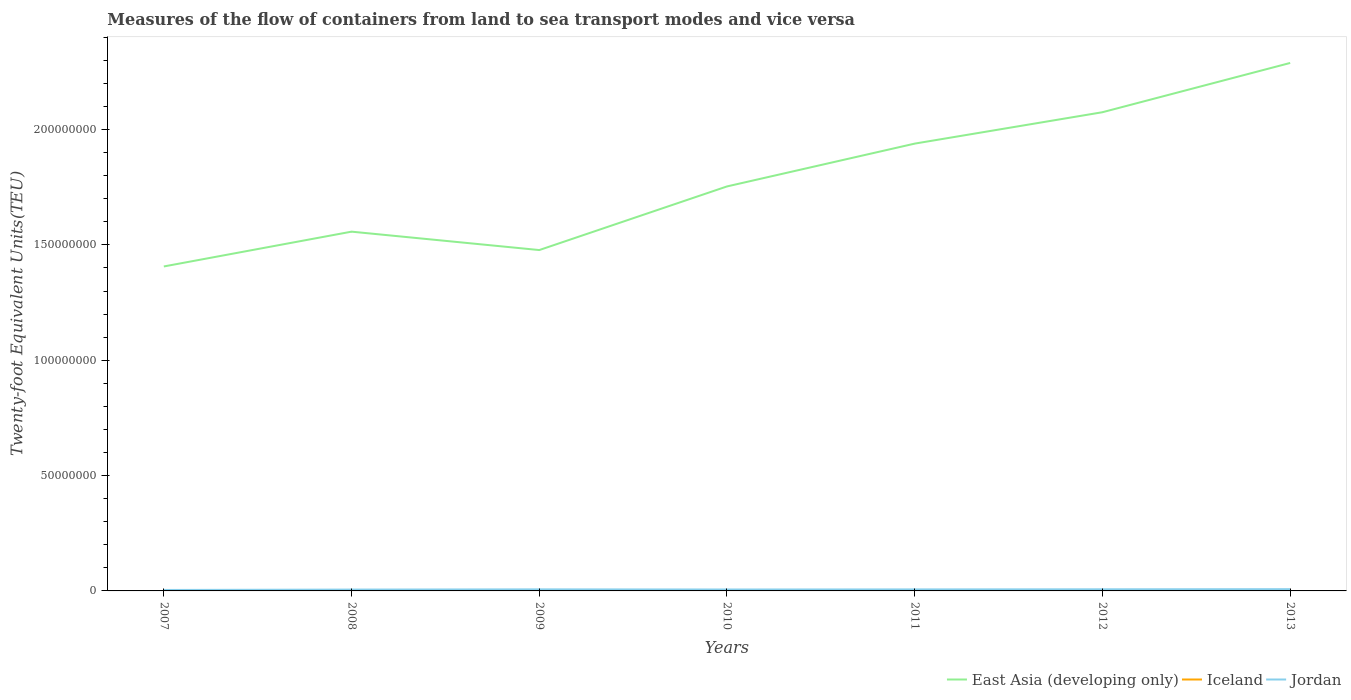Does the line corresponding to Jordan intersect with the line corresponding to East Asia (developing only)?
Offer a terse response. No. Is the number of lines equal to the number of legend labels?
Make the answer very short. Yes. Across all years, what is the maximum container port traffic in Iceland?
Keep it short and to the point. 1.93e+05. In which year was the container port traffic in East Asia (developing only) maximum?
Your answer should be very brief. 2007. What is the total container port traffic in East Asia (developing only) in the graph?
Keep it short and to the point. -6.69e+07. What is the difference between the highest and the second highest container port traffic in Jordan?
Make the answer very short. 3.45e+05. What is the difference between the highest and the lowest container port traffic in Iceland?
Keep it short and to the point. 2. Is the container port traffic in East Asia (developing only) strictly greater than the container port traffic in Iceland over the years?
Give a very brief answer. No. How many lines are there?
Your answer should be compact. 3. How many years are there in the graph?
Provide a short and direct response. 7. Are the values on the major ticks of Y-axis written in scientific E-notation?
Provide a short and direct response. No. Does the graph contain any zero values?
Ensure brevity in your answer.  No. Does the graph contain grids?
Your answer should be very brief. No. Where does the legend appear in the graph?
Provide a succinct answer. Bottom right. How many legend labels are there?
Your answer should be very brief. 3. What is the title of the graph?
Offer a very short reply. Measures of the flow of containers from land to sea transport modes and vice versa. Does "Luxembourg" appear as one of the legend labels in the graph?
Your response must be concise. No. What is the label or title of the Y-axis?
Provide a succinct answer. Twenty-foot Equivalent Units(TEU). What is the Twenty-foot Equivalent Units(TEU) in East Asia (developing only) in 2007?
Your response must be concise. 1.41e+08. What is the Twenty-foot Equivalent Units(TEU) of Iceland in 2007?
Offer a terse response. 2.92e+05. What is the Twenty-foot Equivalent Units(TEU) in Jordan in 2007?
Your answer should be very brief. 4.14e+05. What is the Twenty-foot Equivalent Units(TEU) in East Asia (developing only) in 2008?
Provide a succinct answer. 1.56e+08. What is the Twenty-foot Equivalent Units(TEU) of Iceland in 2008?
Your answer should be very brief. 2.67e+05. What is the Twenty-foot Equivalent Units(TEU) of Jordan in 2008?
Your answer should be compact. 5.83e+05. What is the Twenty-foot Equivalent Units(TEU) in East Asia (developing only) in 2009?
Your answer should be compact. 1.48e+08. What is the Twenty-foot Equivalent Units(TEU) in Iceland in 2009?
Keep it short and to the point. 1.94e+05. What is the Twenty-foot Equivalent Units(TEU) in Jordan in 2009?
Offer a very short reply. 6.75e+05. What is the Twenty-foot Equivalent Units(TEU) of East Asia (developing only) in 2010?
Your answer should be very brief. 1.75e+08. What is the Twenty-foot Equivalent Units(TEU) of Iceland in 2010?
Ensure brevity in your answer.  1.93e+05. What is the Twenty-foot Equivalent Units(TEU) in Jordan in 2010?
Your answer should be compact. 6.19e+05. What is the Twenty-foot Equivalent Units(TEU) in East Asia (developing only) in 2011?
Make the answer very short. 1.94e+08. What is the Twenty-foot Equivalent Units(TEU) in Iceland in 2011?
Your response must be concise. 1.94e+05. What is the Twenty-foot Equivalent Units(TEU) in Jordan in 2011?
Provide a short and direct response. 6.54e+05. What is the Twenty-foot Equivalent Units(TEU) in East Asia (developing only) in 2012?
Offer a terse response. 2.07e+08. What is the Twenty-foot Equivalent Units(TEU) of Iceland in 2012?
Your response must be concise. 2.08e+05. What is the Twenty-foot Equivalent Units(TEU) of Jordan in 2012?
Keep it short and to the point. 7.03e+05. What is the Twenty-foot Equivalent Units(TEU) of East Asia (developing only) in 2013?
Your answer should be compact. 2.29e+08. What is the Twenty-foot Equivalent Units(TEU) in Iceland in 2013?
Make the answer very short. 2.24e+05. What is the Twenty-foot Equivalent Units(TEU) of Jordan in 2013?
Your answer should be compact. 7.59e+05. Across all years, what is the maximum Twenty-foot Equivalent Units(TEU) of East Asia (developing only)?
Give a very brief answer. 2.29e+08. Across all years, what is the maximum Twenty-foot Equivalent Units(TEU) of Iceland?
Provide a short and direct response. 2.92e+05. Across all years, what is the maximum Twenty-foot Equivalent Units(TEU) in Jordan?
Keep it short and to the point. 7.59e+05. Across all years, what is the minimum Twenty-foot Equivalent Units(TEU) in East Asia (developing only)?
Your response must be concise. 1.41e+08. Across all years, what is the minimum Twenty-foot Equivalent Units(TEU) in Iceland?
Your answer should be compact. 1.93e+05. Across all years, what is the minimum Twenty-foot Equivalent Units(TEU) in Jordan?
Your answer should be very brief. 4.14e+05. What is the total Twenty-foot Equivalent Units(TEU) in East Asia (developing only) in the graph?
Provide a short and direct response. 1.25e+09. What is the total Twenty-foot Equivalent Units(TEU) in Iceland in the graph?
Make the answer very short. 1.57e+06. What is the total Twenty-foot Equivalent Units(TEU) in Jordan in the graph?
Make the answer very short. 4.41e+06. What is the difference between the Twenty-foot Equivalent Units(TEU) in East Asia (developing only) in 2007 and that in 2008?
Your answer should be very brief. -1.51e+07. What is the difference between the Twenty-foot Equivalent Units(TEU) of Iceland in 2007 and that in 2008?
Keep it short and to the point. 2.46e+04. What is the difference between the Twenty-foot Equivalent Units(TEU) of Jordan in 2007 and that in 2008?
Ensure brevity in your answer.  -1.69e+05. What is the difference between the Twenty-foot Equivalent Units(TEU) in East Asia (developing only) in 2007 and that in 2009?
Provide a short and direct response. -7.11e+06. What is the difference between the Twenty-foot Equivalent Units(TEU) in Iceland in 2007 and that in 2009?
Give a very brief answer. 9.79e+04. What is the difference between the Twenty-foot Equivalent Units(TEU) in Jordan in 2007 and that in 2009?
Provide a short and direct response. -2.61e+05. What is the difference between the Twenty-foot Equivalent Units(TEU) of East Asia (developing only) in 2007 and that in 2010?
Provide a short and direct response. -3.47e+07. What is the difference between the Twenty-foot Equivalent Units(TEU) of Iceland in 2007 and that in 2010?
Offer a very short reply. 9.90e+04. What is the difference between the Twenty-foot Equivalent Units(TEU) in Jordan in 2007 and that in 2010?
Give a very brief answer. -2.05e+05. What is the difference between the Twenty-foot Equivalent Units(TEU) of East Asia (developing only) in 2007 and that in 2011?
Keep it short and to the point. -5.32e+07. What is the difference between the Twenty-foot Equivalent Units(TEU) of Iceland in 2007 and that in 2011?
Offer a very short reply. 9.82e+04. What is the difference between the Twenty-foot Equivalent Units(TEU) in Jordan in 2007 and that in 2011?
Make the answer very short. -2.40e+05. What is the difference between the Twenty-foot Equivalent Units(TEU) of East Asia (developing only) in 2007 and that in 2012?
Give a very brief answer. -6.69e+07. What is the difference between the Twenty-foot Equivalent Units(TEU) of Iceland in 2007 and that in 2012?
Give a very brief answer. 8.37e+04. What is the difference between the Twenty-foot Equivalent Units(TEU) of Jordan in 2007 and that in 2012?
Your response must be concise. -2.89e+05. What is the difference between the Twenty-foot Equivalent Units(TEU) in East Asia (developing only) in 2007 and that in 2013?
Offer a very short reply. -8.82e+07. What is the difference between the Twenty-foot Equivalent Units(TEU) in Iceland in 2007 and that in 2013?
Ensure brevity in your answer.  6.73e+04. What is the difference between the Twenty-foot Equivalent Units(TEU) of Jordan in 2007 and that in 2013?
Keep it short and to the point. -3.45e+05. What is the difference between the Twenty-foot Equivalent Units(TEU) in East Asia (developing only) in 2008 and that in 2009?
Offer a terse response. 7.97e+06. What is the difference between the Twenty-foot Equivalent Units(TEU) of Iceland in 2008 and that in 2009?
Your answer should be compact. 7.33e+04. What is the difference between the Twenty-foot Equivalent Units(TEU) in Jordan in 2008 and that in 2009?
Offer a terse response. -9.20e+04. What is the difference between the Twenty-foot Equivalent Units(TEU) in East Asia (developing only) in 2008 and that in 2010?
Offer a very short reply. -1.96e+07. What is the difference between the Twenty-foot Equivalent Units(TEU) of Iceland in 2008 and that in 2010?
Offer a terse response. 7.44e+04. What is the difference between the Twenty-foot Equivalent Units(TEU) in Jordan in 2008 and that in 2010?
Offer a terse response. -3.65e+04. What is the difference between the Twenty-foot Equivalent Units(TEU) of East Asia (developing only) in 2008 and that in 2011?
Your answer should be very brief. -3.82e+07. What is the difference between the Twenty-foot Equivalent Units(TEU) of Iceland in 2008 and that in 2011?
Keep it short and to the point. 7.37e+04. What is the difference between the Twenty-foot Equivalent Units(TEU) of Jordan in 2008 and that in 2011?
Offer a terse response. -7.18e+04. What is the difference between the Twenty-foot Equivalent Units(TEU) of East Asia (developing only) in 2008 and that in 2012?
Ensure brevity in your answer.  -5.18e+07. What is the difference between the Twenty-foot Equivalent Units(TEU) of Iceland in 2008 and that in 2012?
Your response must be concise. 5.91e+04. What is the difference between the Twenty-foot Equivalent Units(TEU) in Jordan in 2008 and that in 2012?
Offer a terse response. -1.21e+05. What is the difference between the Twenty-foot Equivalent Units(TEU) in East Asia (developing only) in 2008 and that in 2013?
Provide a short and direct response. -7.31e+07. What is the difference between the Twenty-foot Equivalent Units(TEU) of Iceland in 2008 and that in 2013?
Offer a terse response. 4.27e+04. What is the difference between the Twenty-foot Equivalent Units(TEU) in Jordan in 2008 and that in 2013?
Your answer should be compact. -1.76e+05. What is the difference between the Twenty-foot Equivalent Units(TEU) in East Asia (developing only) in 2009 and that in 2010?
Ensure brevity in your answer.  -2.76e+07. What is the difference between the Twenty-foot Equivalent Units(TEU) in Iceland in 2009 and that in 2010?
Give a very brief answer. 1038. What is the difference between the Twenty-foot Equivalent Units(TEU) in Jordan in 2009 and that in 2010?
Offer a very short reply. 5.55e+04. What is the difference between the Twenty-foot Equivalent Units(TEU) in East Asia (developing only) in 2009 and that in 2011?
Your answer should be very brief. -4.61e+07. What is the difference between the Twenty-foot Equivalent Units(TEU) in Iceland in 2009 and that in 2011?
Ensure brevity in your answer.  316. What is the difference between the Twenty-foot Equivalent Units(TEU) in Jordan in 2009 and that in 2011?
Ensure brevity in your answer.  2.02e+04. What is the difference between the Twenty-foot Equivalent Units(TEU) of East Asia (developing only) in 2009 and that in 2012?
Make the answer very short. -5.97e+07. What is the difference between the Twenty-foot Equivalent Units(TEU) of Iceland in 2009 and that in 2012?
Ensure brevity in your answer.  -1.42e+04. What is the difference between the Twenty-foot Equivalent Units(TEU) in Jordan in 2009 and that in 2012?
Your answer should be compact. -2.88e+04. What is the difference between the Twenty-foot Equivalent Units(TEU) of East Asia (developing only) in 2009 and that in 2013?
Ensure brevity in your answer.  -8.11e+07. What is the difference between the Twenty-foot Equivalent Units(TEU) in Iceland in 2009 and that in 2013?
Keep it short and to the point. -3.06e+04. What is the difference between the Twenty-foot Equivalent Units(TEU) in Jordan in 2009 and that in 2013?
Give a very brief answer. -8.44e+04. What is the difference between the Twenty-foot Equivalent Units(TEU) in East Asia (developing only) in 2010 and that in 2011?
Provide a succinct answer. -1.86e+07. What is the difference between the Twenty-foot Equivalent Units(TEU) in Iceland in 2010 and that in 2011?
Make the answer very short. -722. What is the difference between the Twenty-foot Equivalent Units(TEU) in Jordan in 2010 and that in 2011?
Offer a terse response. -3.53e+04. What is the difference between the Twenty-foot Equivalent Units(TEU) of East Asia (developing only) in 2010 and that in 2012?
Offer a very short reply. -3.22e+07. What is the difference between the Twenty-foot Equivalent Units(TEU) in Iceland in 2010 and that in 2012?
Offer a very short reply. -1.52e+04. What is the difference between the Twenty-foot Equivalent Units(TEU) in Jordan in 2010 and that in 2012?
Your answer should be very brief. -8.44e+04. What is the difference between the Twenty-foot Equivalent Units(TEU) of East Asia (developing only) in 2010 and that in 2013?
Ensure brevity in your answer.  -5.35e+07. What is the difference between the Twenty-foot Equivalent Units(TEU) of Iceland in 2010 and that in 2013?
Offer a very short reply. -3.17e+04. What is the difference between the Twenty-foot Equivalent Units(TEU) of Jordan in 2010 and that in 2013?
Your answer should be very brief. -1.40e+05. What is the difference between the Twenty-foot Equivalent Units(TEU) of East Asia (developing only) in 2011 and that in 2012?
Make the answer very short. -1.36e+07. What is the difference between the Twenty-foot Equivalent Units(TEU) of Iceland in 2011 and that in 2012?
Provide a succinct answer. -1.45e+04. What is the difference between the Twenty-foot Equivalent Units(TEU) of Jordan in 2011 and that in 2012?
Offer a very short reply. -4.91e+04. What is the difference between the Twenty-foot Equivalent Units(TEU) in East Asia (developing only) in 2011 and that in 2013?
Your response must be concise. -3.50e+07. What is the difference between the Twenty-foot Equivalent Units(TEU) of Iceland in 2011 and that in 2013?
Your answer should be very brief. -3.09e+04. What is the difference between the Twenty-foot Equivalent Units(TEU) in Jordan in 2011 and that in 2013?
Provide a short and direct response. -1.05e+05. What is the difference between the Twenty-foot Equivalent Units(TEU) of East Asia (developing only) in 2012 and that in 2013?
Your answer should be compact. -2.14e+07. What is the difference between the Twenty-foot Equivalent Units(TEU) of Iceland in 2012 and that in 2013?
Offer a terse response. -1.64e+04. What is the difference between the Twenty-foot Equivalent Units(TEU) of Jordan in 2012 and that in 2013?
Provide a succinct answer. -5.56e+04. What is the difference between the Twenty-foot Equivalent Units(TEU) in East Asia (developing only) in 2007 and the Twenty-foot Equivalent Units(TEU) in Iceland in 2008?
Give a very brief answer. 1.40e+08. What is the difference between the Twenty-foot Equivalent Units(TEU) of East Asia (developing only) in 2007 and the Twenty-foot Equivalent Units(TEU) of Jordan in 2008?
Provide a succinct answer. 1.40e+08. What is the difference between the Twenty-foot Equivalent Units(TEU) of Iceland in 2007 and the Twenty-foot Equivalent Units(TEU) of Jordan in 2008?
Offer a very short reply. -2.91e+05. What is the difference between the Twenty-foot Equivalent Units(TEU) of East Asia (developing only) in 2007 and the Twenty-foot Equivalent Units(TEU) of Iceland in 2009?
Your answer should be very brief. 1.40e+08. What is the difference between the Twenty-foot Equivalent Units(TEU) of East Asia (developing only) in 2007 and the Twenty-foot Equivalent Units(TEU) of Jordan in 2009?
Your response must be concise. 1.40e+08. What is the difference between the Twenty-foot Equivalent Units(TEU) in Iceland in 2007 and the Twenty-foot Equivalent Units(TEU) in Jordan in 2009?
Offer a terse response. -3.83e+05. What is the difference between the Twenty-foot Equivalent Units(TEU) in East Asia (developing only) in 2007 and the Twenty-foot Equivalent Units(TEU) in Iceland in 2010?
Provide a short and direct response. 1.40e+08. What is the difference between the Twenty-foot Equivalent Units(TEU) in East Asia (developing only) in 2007 and the Twenty-foot Equivalent Units(TEU) in Jordan in 2010?
Keep it short and to the point. 1.40e+08. What is the difference between the Twenty-foot Equivalent Units(TEU) of Iceland in 2007 and the Twenty-foot Equivalent Units(TEU) of Jordan in 2010?
Your answer should be very brief. -3.27e+05. What is the difference between the Twenty-foot Equivalent Units(TEU) in East Asia (developing only) in 2007 and the Twenty-foot Equivalent Units(TEU) in Iceland in 2011?
Offer a very short reply. 1.40e+08. What is the difference between the Twenty-foot Equivalent Units(TEU) of East Asia (developing only) in 2007 and the Twenty-foot Equivalent Units(TEU) of Jordan in 2011?
Your answer should be compact. 1.40e+08. What is the difference between the Twenty-foot Equivalent Units(TEU) of Iceland in 2007 and the Twenty-foot Equivalent Units(TEU) of Jordan in 2011?
Your answer should be very brief. -3.63e+05. What is the difference between the Twenty-foot Equivalent Units(TEU) in East Asia (developing only) in 2007 and the Twenty-foot Equivalent Units(TEU) in Iceland in 2012?
Your response must be concise. 1.40e+08. What is the difference between the Twenty-foot Equivalent Units(TEU) in East Asia (developing only) in 2007 and the Twenty-foot Equivalent Units(TEU) in Jordan in 2012?
Offer a terse response. 1.40e+08. What is the difference between the Twenty-foot Equivalent Units(TEU) in Iceland in 2007 and the Twenty-foot Equivalent Units(TEU) in Jordan in 2012?
Offer a very short reply. -4.12e+05. What is the difference between the Twenty-foot Equivalent Units(TEU) in East Asia (developing only) in 2007 and the Twenty-foot Equivalent Units(TEU) in Iceland in 2013?
Give a very brief answer. 1.40e+08. What is the difference between the Twenty-foot Equivalent Units(TEU) of East Asia (developing only) in 2007 and the Twenty-foot Equivalent Units(TEU) of Jordan in 2013?
Provide a short and direct response. 1.40e+08. What is the difference between the Twenty-foot Equivalent Units(TEU) of Iceland in 2007 and the Twenty-foot Equivalent Units(TEU) of Jordan in 2013?
Keep it short and to the point. -4.67e+05. What is the difference between the Twenty-foot Equivalent Units(TEU) in East Asia (developing only) in 2008 and the Twenty-foot Equivalent Units(TEU) in Iceland in 2009?
Your answer should be compact. 1.56e+08. What is the difference between the Twenty-foot Equivalent Units(TEU) of East Asia (developing only) in 2008 and the Twenty-foot Equivalent Units(TEU) of Jordan in 2009?
Provide a succinct answer. 1.55e+08. What is the difference between the Twenty-foot Equivalent Units(TEU) in Iceland in 2008 and the Twenty-foot Equivalent Units(TEU) in Jordan in 2009?
Provide a short and direct response. -4.07e+05. What is the difference between the Twenty-foot Equivalent Units(TEU) in East Asia (developing only) in 2008 and the Twenty-foot Equivalent Units(TEU) in Iceland in 2010?
Provide a succinct answer. 1.56e+08. What is the difference between the Twenty-foot Equivalent Units(TEU) of East Asia (developing only) in 2008 and the Twenty-foot Equivalent Units(TEU) of Jordan in 2010?
Your answer should be very brief. 1.55e+08. What is the difference between the Twenty-foot Equivalent Units(TEU) of Iceland in 2008 and the Twenty-foot Equivalent Units(TEU) of Jordan in 2010?
Offer a terse response. -3.52e+05. What is the difference between the Twenty-foot Equivalent Units(TEU) in East Asia (developing only) in 2008 and the Twenty-foot Equivalent Units(TEU) in Iceland in 2011?
Provide a succinct answer. 1.56e+08. What is the difference between the Twenty-foot Equivalent Units(TEU) of East Asia (developing only) in 2008 and the Twenty-foot Equivalent Units(TEU) of Jordan in 2011?
Keep it short and to the point. 1.55e+08. What is the difference between the Twenty-foot Equivalent Units(TEU) of Iceland in 2008 and the Twenty-foot Equivalent Units(TEU) of Jordan in 2011?
Ensure brevity in your answer.  -3.87e+05. What is the difference between the Twenty-foot Equivalent Units(TEU) of East Asia (developing only) in 2008 and the Twenty-foot Equivalent Units(TEU) of Iceland in 2012?
Ensure brevity in your answer.  1.56e+08. What is the difference between the Twenty-foot Equivalent Units(TEU) in East Asia (developing only) in 2008 and the Twenty-foot Equivalent Units(TEU) in Jordan in 2012?
Keep it short and to the point. 1.55e+08. What is the difference between the Twenty-foot Equivalent Units(TEU) of Iceland in 2008 and the Twenty-foot Equivalent Units(TEU) of Jordan in 2012?
Your response must be concise. -4.36e+05. What is the difference between the Twenty-foot Equivalent Units(TEU) in East Asia (developing only) in 2008 and the Twenty-foot Equivalent Units(TEU) in Iceland in 2013?
Provide a succinct answer. 1.56e+08. What is the difference between the Twenty-foot Equivalent Units(TEU) in East Asia (developing only) in 2008 and the Twenty-foot Equivalent Units(TEU) in Jordan in 2013?
Your answer should be compact. 1.55e+08. What is the difference between the Twenty-foot Equivalent Units(TEU) of Iceland in 2008 and the Twenty-foot Equivalent Units(TEU) of Jordan in 2013?
Keep it short and to the point. -4.92e+05. What is the difference between the Twenty-foot Equivalent Units(TEU) in East Asia (developing only) in 2009 and the Twenty-foot Equivalent Units(TEU) in Iceland in 2010?
Ensure brevity in your answer.  1.48e+08. What is the difference between the Twenty-foot Equivalent Units(TEU) of East Asia (developing only) in 2009 and the Twenty-foot Equivalent Units(TEU) of Jordan in 2010?
Give a very brief answer. 1.47e+08. What is the difference between the Twenty-foot Equivalent Units(TEU) in Iceland in 2009 and the Twenty-foot Equivalent Units(TEU) in Jordan in 2010?
Make the answer very short. -4.25e+05. What is the difference between the Twenty-foot Equivalent Units(TEU) in East Asia (developing only) in 2009 and the Twenty-foot Equivalent Units(TEU) in Iceland in 2011?
Offer a terse response. 1.48e+08. What is the difference between the Twenty-foot Equivalent Units(TEU) in East Asia (developing only) in 2009 and the Twenty-foot Equivalent Units(TEU) in Jordan in 2011?
Your answer should be very brief. 1.47e+08. What is the difference between the Twenty-foot Equivalent Units(TEU) in Iceland in 2009 and the Twenty-foot Equivalent Units(TEU) in Jordan in 2011?
Ensure brevity in your answer.  -4.60e+05. What is the difference between the Twenty-foot Equivalent Units(TEU) in East Asia (developing only) in 2009 and the Twenty-foot Equivalent Units(TEU) in Iceland in 2012?
Provide a succinct answer. 1.48e+08. What is the difference between the Twenty-foot Equivalent Units(TEU) of East Asia (developing only) in 2009 and the Twenty-foot Equivalent Units(TEU) of Jordan in 2012?
Make the answer very short. 1.47e+08. What is the difference between the Twenty-foot Equivalent Units(TEU) in Iceland in 2009 and the Twenty-foot Equivalent Units(TEU) in Jordan in 2012?
Make the answer very short. -5.10e+05. What is the difference between the Twenty-foot Equivalent Units(TEU) of East Asia (developing only) in 2009 and the Twenty-foot Equivalent Units(TEU) of Iceland in 2013?
Give a very brief answer. 1.48e+08. What is the difference between the Twenty-foot Equivalent Units(TEU) in East Asia (developing only) in 2009 and the Twenty-foot Equivalent Units(TEU) in Jordan in 2013?
Provide a succinct answer. 1.47e+08. What is the difference between the Twenty-foot Equivalent Units(TEU) in Iceland in 2009 and the Twenty-foot Equivalent Units(TEU) in Jordan in 2013?
Make the answer very short. -5.65e+05. What is the difference between the Twenty-foot Equivalent Units(TEU) in East Asia (developing only) in 2010 and the Twenty-foot Equivalent Units(TEU) in Iceland in 2011?
Your answer should be compact. 1.75e+08. What is the difference between the Twenty-foot Equivalent Units(TEU) of East Asia (developing only) in 2010 and the Twenty-foot Equivalent Units(TEU) of Jordan in 2011?
Make the answer very short. 1.75e+08. What is the difference between the Twenty-foot Equivalent Units(TEU) of Iceland in 2010 and the Twenty-foot Equivalent Units(TEU) of Jordan in 2011?
Provide a succinct answer. -4.62e+05. What is the difference between the Twenty-foot Equivalent Units(TEU) of East Asia (developing only) in 2010 and the Twenty-foot Equivalent Units(TEU) of Iceland in 2012?
Make the answer very short. 1.75e+08. What is the difference between the Twenty-foot Equivalent Units(TEU) in East Asia (developing only) in 2010 and the Twenty-foot Equivalent Units(TEU) in Jordan in 2012?
Provide a short and direct response. 1.75e+08. What is the difference between the Twenty-foot Equivalent Units(TEU) of Iceland in 2010 and the Twenty-foot Equivalent Units(TEU) of Jordan in 2012?
Give a very brief answer. -5.11e+05. What is the difference between the Twenty-foot Equivalent Units(TEU) of East Asia (developing only) in 2010 and the Twenty-foot Equivalent Units(TEU) of Iceland in 2013?
Give a very brief answer. 1.75e+08. What is the difference between the Twenty-foot Equivalent Units(TEU) in East Asia (developing only) in 2010 and the Twenty-foot Equivalent Units(TEU) in Jordan in 2013?
Your response must be concise. 1.75e+08. What is the difference between the Twenty-foot Equivalent Units(TEU) of Iceland in 2010 and the Twenty-foot Equivalent Units(TEU) of Jordan in 2013?
Offer a very short reply. -5.66e+05. What is the difference between the Twenty-foot Equivalent Units(TEU) of East Asia (developing only) in 2011 and the Twenty-foot Equivalent Units(TEU) of Iceland in 2012?
Provide a short and direct response. 1.94e+08. What is the difference between the Twenty-foot Equivalent Units(TEU) in East Asia (developing only) in 2011 and the Twenty-foot Equivalent Units(TEU) in Jordan in 2012?
Offer a very short reply. 1.93e+08. What is the difference between the Twenty-foot Equivalent Units(TEU) in Iceland in 2011 and the Twenty-foot Equivalent Units(TEU) in Jordan in 2012?
Your answer should be compact. -5.10e+05. What is the difference between the Twenty-foot Equivalent Units(TEU) of East Asia (developing only) in 2011 and the Twenty-foot Equivalent Units(TEU) of Iceland in 2013?
Offer a terse response. 1.94e+08. What is the difference between the Twenty-foot Equivalent Units(TEU) in East Asia (developing only) in 2011 and the Twenty-foot Equivalent Units(TEU) in Jordan in 2013?
Make the answer very short. 1.93e+08. What is the difference between the Twenty-foot Equivalent Units(TEU) in Iceland in 2011 and the Twenty-foot Equivalent Units(TEU) in Jordan in 2013?
Give a very brief answer. -5.65e+05. What is the difference between the Twenty-foot Equivalent Units(TEU) of East Asia (developing only) in 2012 and the Twenty-foot Equivalent Units(TEU) of Iceland in 2013?
Offer a very short reply. 2.07e+08. What is the difference between the Twenty-foot Equivalent Units(TEU) of East Asia (developing only) in 2012 and the Twenty-foot Equivalent Units(TEU) of Jordan in 2013?
Your answer should be compact. 2.07e+08. What is the difference between the Twenty-foot Equivalent Units(TEU) of Iceland in 2012 and the Twenty-foot Equivalent Units(TEU) of Jordan in 2013?
Keep it short and to the point. -5.51e+05. What is the average Twenty-foot Equivalent Units(TEU) of East Asia (developing only) per year?
Provide a short and direct response. 1.79e+08. What is the average Twenty-foot Equivalent Units(TEU) of Iceland per year?
Your answer should be very brief. 2.24e+05. What is the average Twenty-foot Equivalent Units(TEU) of Jordan per year?
Make the answer very short. 6.30e+05. In the year 2007, what is the difference between the Twenty-foot Equivalent Units(TEU) in East Asia (developing only) and Twenty-foot Equivalent Units(TEU) in Iceland?
Provide a short and direct response. 1.40e+08. In the year 2007, what is the difference between the Twenty-foot Equivalent Units(TEU) of East Asia (developing only) and Twenty-foot Equivalent Units(TEU) of Jordan?
Your answer should be very brief. 1.40e+08. In the year 2007, what is the difference between the Twenty-foot Equivalent Units(TEU) in Iceland and Twenty-foot Equivalent Units(TEU) in Jordan?
Give a very brief answer. -1.22e+05. In the year 2008, what is the difference between the Twenty-foot Equivalent Units(TEU) of East Asia (developing only) and Twenty-foot Equivalent Units(TEU) of Iceland?
Ensure brevity in your answer.  1.55e+08. In the year 2008, what is the difference between the Twenty-foot Equivalent Units(TEU) in East Asia (developing only) and Twenty-foot Equivalent Units(TEU) in Jordan?
Your response must be concise. 1.55e+08. In the year 2008, what is the difference between the Twenty-foot Equivalent Units(TEU) in Iceland and Twenty-foot Equivalent Units(TEU) in Jordan?
Keep it short and to the point. -3.15e+05. In the year 2009, what is the difference between the Twenty-foot Equivalent Units(TEU) in East Asia (developing only) and Twenty-foot Equivalent Units(TEU) in Iceland?
Offer a very short reply. 1.48e+08. In the year 2009, what is the difference between the Twenty-foot Equivalent Units(TEU) in East Asia (developing only) and Twenty-foot Equivalent Units(TEU) in Jordan?
Your answer should be compact. 1.47e+08. In the year 2009, what is the difference between the Twenty-foot Equivalent Units(TEU) of Iceland and Twenty-foot Equivalent Units(TEU) of Jordan?
Offer a very short reply. -4.81e+05. In the year 2010, what is the difference between the Twenty-foot Equivalent Units(TEU) in East Asia (developing only) and Twenty-foot Equivalent Units(TEU) in Iceland?
Ensure brevity in your answer.  1.75e+08. In the year 2010, what is the difference between the Twenty-foot Equivalent Units(TEU) of East Asia (developing only) and Twenty-foot Equivalent Units(TEU) of Jordan?
Your response must be concise. 1.75e+08. In the year 2010, what is the difference between the Twenty-foot Equivalent Units(TEU) in Iceland and Twenty-foot Equivalent Units(TEU) in Jordan?
Make the answer very short. -4.26e+05. In the year 2011, what is the difference between the Twenty-foot Equivalent Units(TEU) in East Asia (developing only) and Twenty-foot Equivalent Units(TEU) in Iceland?
Offer a very short reply. 1.94e+08. In the year 2011, what is the difference between the Twenty-foot Equivalent Units(TEU) in East Asia (developing only) and Twenty-foot Equivalent Units(TEU) in Jordan?
Your answer should be very brief. 1.93e+08. In the year 2011, what is the difference between the Twenty-foot Equivalent Units(TEU) of Iceland and Twenty-foot Equivalent Units(TEU) of Jordan?
Make the answer very short. -4.61e+05. In the year 2012, what is the difference between the Twenty-foot Equivalent Units(TEU) in East Asia (developing only) and Twenty-foot Equivalent Units(TEU) in Iceland?
Your answer should be very brief. 2.07e+08. In the year 2012, what is the difference between the Twenty-foot Equivalent Units(TEU) in East Asia (developing only) and Twenty-foot Equivalent Units(TEU) in Jordan?
Offer a very short reply. 2.07e+08. In the year 2012, what is the difference between the Twenty-foot Equivalent Units(TEU) of Iceland and Twenty-foot Equivalent Units(TEU) of Jordan?
Keep it short and to the point. -4.95e+05. In the year 2013, what is the difference between the Twenty-foot Equivalent Units(TEU) of East Asia (developing only) and Twenty-foot Equivalent Units(TEU) of Iceland?
Ensure brevity in your answer.  2.29e+08. In the year 2013, what is the difference between the Twenty-foot Equivalent Units(TEU) of East Asia (developing only) and Twenty-foot Equivalent Units(TEU) of Jordan?
Your answer should be compact. 2.28e+08. In the year 2013, what is the difference between the Twenty-foot Equivalent Units(TEU) of Iceland and Twenty-foot Equivalent Units(TEU) of Jordan?
Your answer should be very brief. -5.34e+05. What is the ratio of the Twenty-foot Equivalent Units(TEU) of East Asia (developing only) in 2007 to that in 2008?
Provide a short and direct response. 0.9. What is the ratio of the Twenty-foot Equivalent Units(TEU) in Iceland in 2007 to that in 2008?
Your response must be concise. 1.09. What is the ratio of the Twenty-foot Equivalent Units(TEU) of Jordan in 2007 to that in 2008?
Offer a very short reply. 0.71. What is the ratio of the Twenty-foot Equivalent Units(TEU) in East Asia (developing only) in 2007 to that in 2009?
Provide a succinct answer. 0.95. What is the ratio of the Twenty-foot Equivalent Units(TEU) in Iceland in 2007 to that in 2009?
Provide a short and direct response. 1.51. What is the ratio of the Twenty-foot Equivalent Units(TEU) in Jordan in 2007 to that in 2009?
Provide a short and direct response. 0.61. What is the ratio of the Twenty-foot Equivalent Units(TEU) of East Asia (developing only) in 2007 to that in 2010?
Make the answer very short. 0.8. What is the ratio of the Twenty-foot Equivalent Units(TEU) of Iceland in 2007 to that in 2010?
Make the answer very short. 1.51. What is the ratio of the Twenty-foot Equivalent Units(TEU) in Jordan in 2007 to that in 2010?
Give a very brief answer. 0.67. What is the ratio of the Twenty-foot Equivalent Units(TEU) of East Asia (developing only) in 2007 to that in 2011?
Give a very brief answer. 0.73. What is the ratio of the Twenty-foot Equivalent Units(TEU) in Iceland in 2007 to that in 2011?
Ensure brevity in your answer.  1.51. What is the ratio of the Twenty-foot Equivalent Units(TEU) in Jordan in 2007 to that in 2011?
Your answer should be very brief. 0.63. What is the ratio of the Twenty-foot Equivalent Units(TEU) in East Asia (developing only) in 2007 to that in 2012?
Make the answer very short. 0.68. What is the ratio of the Twenty-foot Equivalent Units(TEU) of Iceland in 2007 to that in 2012?
Give a very brief answer. 1.4. What is the ratio of the Twenty-foot Equivalent Units(TEU) of Jordan in 2007 to that in 2012?
Your response must be concise. 0.59. What is the ratio of the Twenty-foot Equivalent Units(TEU) in East Asia (developing only) in 2007 to that in 2013?
Provide a succinct answer. 0.61. What is the ratio of the Twenty-foot Equivalent Units(TEU) in Iceland in 2007 to that in 2013?
Provide a succinct answer. 1.3. What is the ratio of the Twenty-foot Equivalent Units(TEU) in Jordan in 2007 to that in 2013?
Give a very brief answer. 0.55. What is the ratio of the Twenty-foot Equivalent Units(TEU) in East Asia (developing only) in 2008 to that in 2009?
Make the answer very short. 1.05. What is the ratio of the Twenty-foot Equivalent Units(TEU) in Iceland in 2008 to that in 2009?
Offer a terse response. 1.38. What is the ratio of the Twenty-foot Equivalent Units(TEU) of Jordan in 2008 to that in 2009?
Your response must be concise. 0.86. What is the ratio of the Twenty-foot Equivalent Units(TEU) of East Asia (developing only) in 2008 to that in 2010?
Keep it short and to the point. 0.89. What is the ratio of the Twenty-foot Equivalent Units(TEU) in Iceland in 2008 to that in 2010?
Make the answer very short. 1.39. What is the ratio of the Twenty-foot Equivalent Units(TEU) of Jordan in 2008 to that in 2010?
Keep it short and to the point. 0.94. What is the ratio of the Twenty-foot Equivalent Units(TEU) of East Asia (developing only) in 2008 to that in 2011?
Provide a short and direct response. 0.8. What is the ratio of the Twenty-foot Equivalent Units(TEU) of Iceland in 2008 to that in 2011?
Your answer should be very brief. 1.38. What is the ratio of the Twenty-foot Equivalent Units(TEU) in Jordan in 2008 to that in 2011?
Offer a terse response. 0.89. What is the ratio of the Twenty-foot Equivalent Units(TEU) of East Asia (developing only) in 2008 to that in 2012?
Offer a very short reply. 0.75. What is the ratio of the Twenty-foot Equivalent Units(TEU) of Iceland in 2008 to that in 2012?
Ensure brevity in your answer.  1.28. What is the ratio of the Twenty-foot Equivalent Units(TEU) in Jordan in 2008 to that in 2012?
Provide a succinct answer. 0.83. What is the ratio of the Twenty-foot Equivalent Units(TEU) of East Asia (developing only) in 2008 to that in 2013?
Make the answer very short. 0.68. What is the ratio of the Twenty-foot Equivalent Units(TEU) in Iceland in 2008 to that in 2013?
Give a very brief answer. 1.19. What is the ratio of the Twenty-foot Equivalent Units(TEU) in Jordan in 2008 to that in 2013?
Your answer should be compact. 0.77. What is the ratio of the Twenty-foot Equivalent Units(TEU) of East Asia (developing only) in 2009 to that in 2010?
Make the answer very short. 0.84. What is the ratio of the Twenty-foot Equivalent Units(TEU) in Iceland in 2009 to that in 2010?
Make the answer very short. 1.01. What is the ratio of the Twenty-foot Equivalent Units(TEU) of Jordan in 2009 to that in 2010?
Ensure brevity in your answer.  1.09. What is the ratio of the Twenty-foot Equivalent Units(TEU) in East Asia (developing only) in 2009 to that in 2011?
Your answer should be very brief. 0.76. What is the ratio of the Twenty-foot Equivalent Units(TEU) of Iceland in 2009 to that in 2011?
Make the answer very short. 1. What is the ratio of the Twenty-foot Equivalent Units(TEU) in Jordan in 2009 to that in 2011?
Provide a short and direct response. 1.03. What is the ratio of the Twenty-foot Equivalent Units(TEU) in East Asia (developing only) in 2009 to that in 2012?
Keep it short and to the point. 0.71. What is the ratio of the Twenty-foot Equivalent Units(TEU) in Iceland in 2009 to that in 2012?
Make the answer very short. 0.93. What is the ratio of the Twenty-foot Equivalent Units(TEU) in Jordan in 2009 to that in 2012?
Your answer should be very brief. 0.96. What is the ratio of the Twenty-foot Equivalent Units(TEU) of East Asia (developing only) in 2009 to that in 2013?
Your answer should be very brief. 0.65. What is the ratio of the Twenty-foot Equivalent Units(TEU) in Iceland in 2009 to that in 2013?
Give a very brief answer. 0.86. What is the ratio of the Twenty-foot Equivalent Units(TEU) of Jordan in 2009 to that in 2013?
Give a very brief answer. 0.89. What is the ratio of the Twenty-foot Equivalent Units(TEU) in East Asia (developing only) in 2010 to that in 2011?
Provide a succinct answer. 0.9. What is the ratio of the Twenty-foot Equivalent Units(TEU) of Iceland in 2010 to that in 2011?
Your answer should be very brief. 1. What is the ratio of the Twenty-foot Equivalent Units(TEU) of Jordan in 2010 to that in 2011?
Offer a terse response. 0.95. What is the ratio of the Twenty-foot Equivalent Units(TEU) of East Asia (developing only) in 2010 to that in 2012?
Your answer should be very brief. 0.84. What is the ratio of the Twenty-foot Equivalent Units(TEU) in Iceland in 2010 to that in 2012?
Give a very brief answer. 0.93. What is the ratio of the Twenty-foot Equivalent Units(TEU) of Jordan in 2010 to that in 2012?
Ensure brevity in your answer.  0.88. What is the ratio of the Twenty-foot Equivalent Units(TEU) of East Asia (developing only) in 2010 to that in 2013?
Your answer should be very brief. 0.77. What is the ratio of the Twenty-foot Equivalent Units(TEU) in Iceland in 2010 to that in 2013?
Provide a succinct answer. 0.86. What is the ratio of the Twenty-foot Equivalent Units(TEU) of Jordan in 2010 to that in 2013?
Offer a terse response. 0.82. What is the ratio of the Twenty-foot Equivalent Units(TEU) in East Asia (developing only) in 2011 to that in 2012?
Provide a succinct answer. 0.93. What is the ratio of the Twenty-foot Equivalent Units(TEU) in Iceland in 2011 to that in 2012?
Your answer should be compact. 0.93. What is the ratio of the Twenty-foot Equivalent Units(TEU) of Jordan in 2011 to that in 2012?
Your answer should be compact. 0.93. What is the ratio of the Twenty-foot Equivalent Units(TEU) in East Asia (developing only) in 2011 to that in 2013?
Give a very brief answer. 0.85. What is the ratio of the Twenty-foot Equivalent Units(TEU) of Iceland in 2011 to that in 2013?
Your answer should be compact. 0.86. What is the ratio of the Twenty-foot Equivalent Units(TEU) in Jordan in 2011 to that in 2013?
Offer a terse response. 0.86. What is the ratio of the Twenty-foot Equivalent Units(TEU) of East Asia (developing only) in 2012 to that in 2013?
Offer a very short reply. 0.91. What is the ratio of the Twenty-foot Equivalent Units(TEU) of Iceland in 2012 to that in 2013?
Give a very brief answer. 0.93. What is the ratio of the Twenty-foot Equivalent Units(TEU) of Jordan in 2012 to that in 2013?
Your answer should be compact. 0.93. What is the difference between the highest and the second highest Twenty-foot Equivalent Units(TEU) in East Asia (developing only)?
Provide a succinct answer. 2.14e+07. What is the difference between the highest and the second highest Twenty-foot Equivalent Units(TEU) in Iceland?
Offer a very short reply. 2.46e+04. What is the difference between the highest and the second highest Twenty-foot Equivalent Units(TEU) in Jordan?
Your answer should be compact. 5.56e+04. What is the difference between the highest and the lowest Twenty-foot Equivalent Units(TEU) in East Asia (developing only)?
Give a very brief answer. 8.82e+07. What is the difference between the highest and the lowest Twenty-foot Equivalent Units(TEU) in Iceland?
Give a very brief answer. 9.90e+04. What is the difference between the highest and the lowest Twenty-foot Equivalent Units(TEU) in Jordan?
Your answer should be very brief. 3.45e+05. 